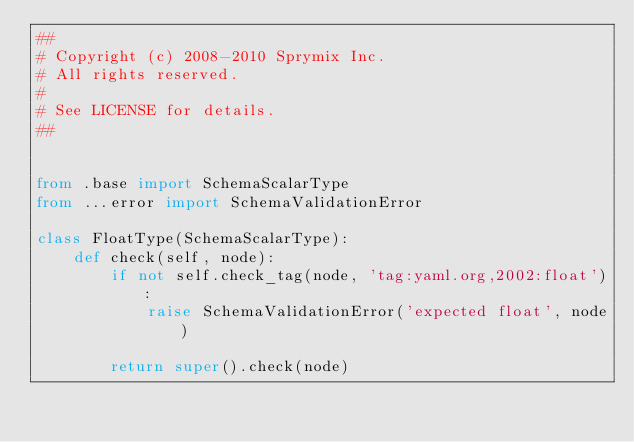<code> <loc_0><loc_0><loc_500><loc_500><_Python_>##
# Copyright (c) 2008-2010 Sprymix Inc.
# All rights reserved.
#
# See LICENSE for details.
##


from .base import SchemaScalarType
from ...error import SchemaValidationError

class FloatType(SchemaScalarType):
    def check(self, node):
        if not self.check_tag(node, 'tag:yaml.org,2002:float'):
            raise SchemaValidationError('expected float', node)

        return super().check(node)
</code> 